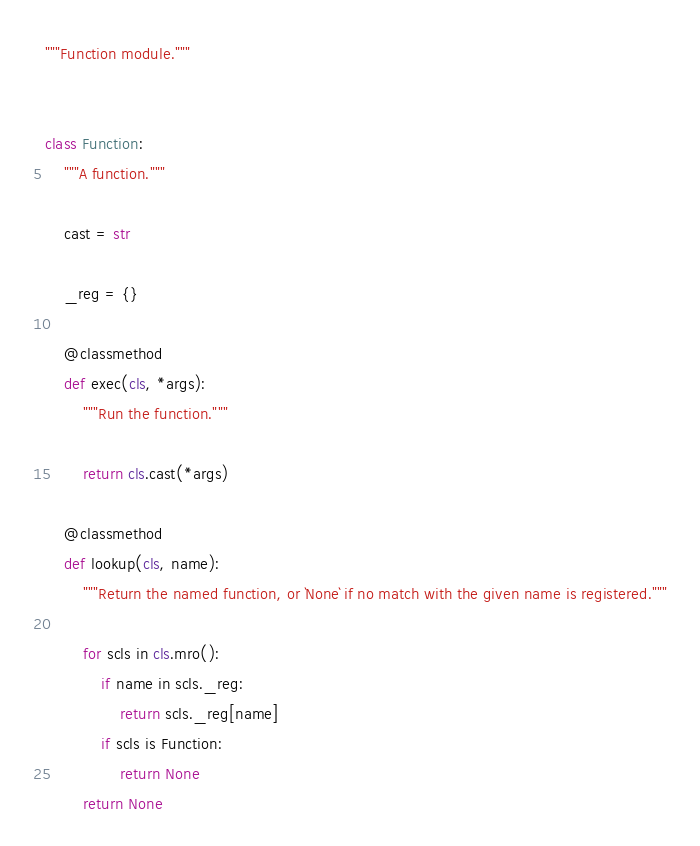<code> <loc_0><loc_0><loc_500><loc_500><_Python_>"""Function module."""


class Function:
    """A function."""

    cast = str

    _reg = {}

    @classmethod
    def exec(cls, *args):
        """Run the function."""

        return cls.cast(*args)

    @classmethod
    def lookup(cls, name):
        """Return the named function, or `None` if no match with the given name is registered."""

        for scls in cls.mro():
            if name in scls._reg:
                return scls._reg[name]
            if scls is Function:
                return None
        return None
</code> 